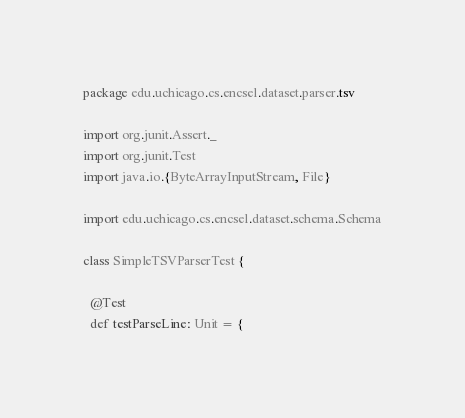Convert code to text. <code><loc_0><loc_0><loc_500><loc_500><_Scala_>package edu.uchicago.cs.encsel.dataset.parser.tsv

import org.junit.Assert._
import org.junit.Test
import java.io.{ByteArrayInputStream, File}

import edu.uchicago.cs.encsel.dataset.schema.Schema

class SimpleTSVParserTest {

  @Test
  def testParseLine: Unit = {</code> 